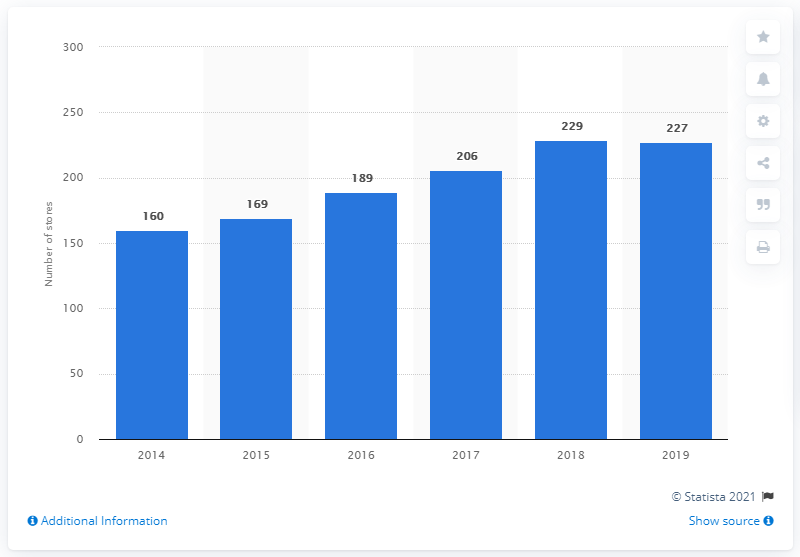Draw attention to some important aspects in this diagram. In 2019, Steve Madden operated 227 retail stores. 